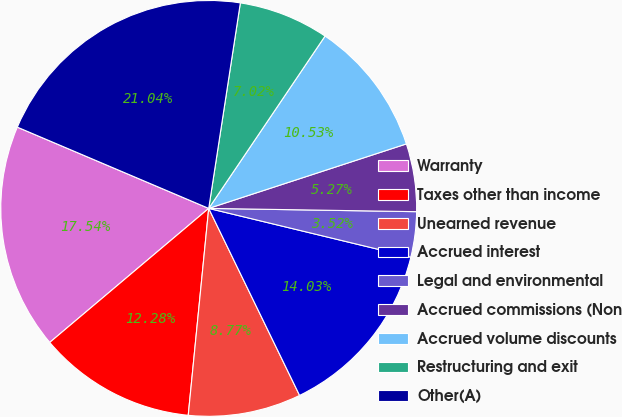Convert chart to OTSL. <chart><loc_0><loc_0><loc_500><loc_500><pie_chart><fcel>Warranty<fcel>Taxes other than income<fcel>Unearned revenue<fcel>Accrued interest<fcel>Legal and environmental<fcel>Accrued commissions (Non<fcel>Accrued volume discounts<fcel>Restructuring and exit<fcel>Other(A)<nl><fcel>17.54%<fcel>12.28%<fcel>8.77%<fcel>14.03%<fcel>3.52%<fcel>5.27%<fcel>10.53%<fcel>7.02%<fcel>21.04%<nl></chart> 